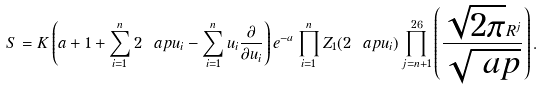Convert formula to latex. <formula><loc_0><loc_0><loc_500><loc_500>S = K \left ( a + 1 + \sum _ { i = 1 } ^ { n } 2 \ a p u _ { i } - \sum _ { i = 1 } ^ { n } u _ { i } \frac { \partial } { \partial u _ { i } } \right ) e ^ { - a } \prod _ { i = 1 } ^ { n } Z _ { 1 } ( 2 \ a p u _ { i } ) \prod _ { j = n + 1 } ^ { 2 6 } \left ( \frac { \sqrt { 2 \pi } R ^ { j } } { \sqrt { \ a p } } \right ) .</formula> 